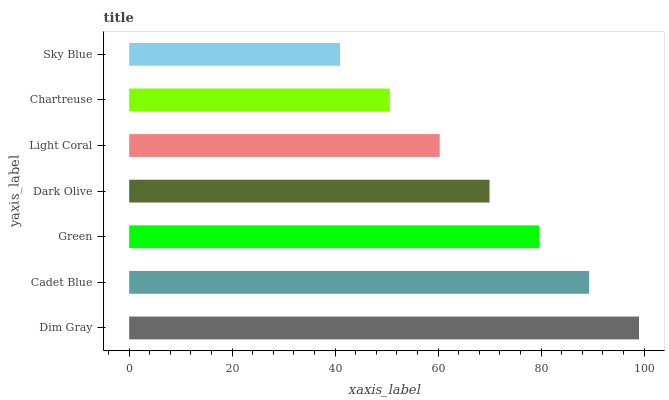Is Sky Blue the minimum?
Answer yes or no. Yes. Is Dim Gray the maximum?
Answer yes or no. Yes. Is Cadet Blue the minimum?
Answer yes or no. No. Is Cadet Blue the maximum?
Answer yes or no. No. Is Dim Gray greater than Cadet Blue?
Answer yes or no. Yes. Is Cadet Blue less than Dim Gray?
Answer yes or no. Yes. Is Cadet Blue greater than Dim Gray?
Answer yes or no. No. Is Dim Gray less than Cadet Blue?
Answer yes or no. No. Is Dark Olive the high median?
Answer yes or no. Yes. Is Dark Olive the low median?
Answer yes or no. Yes. Is Dim Gray the high median?
Answer yes or no. No. Is Cadet Blue the low median?
Answer yes or no. No. 